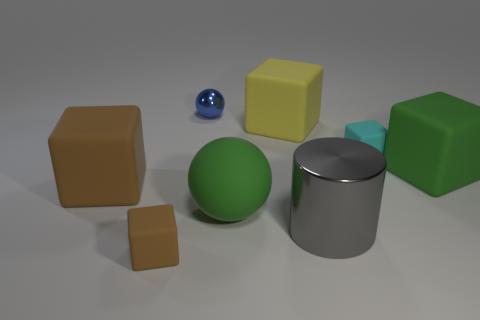Subtract 1 blocks. How many blocks are left? 4 Subtract all cyan rubber blocks. How many blocks are left? 4 Subtract all red cubes. Subtract all red cylinders. How many cubes are left? 5 Add 1 green blocks. How many objects exist? 9 Subtract all cylinders. How many objects are left? 7 Add 3 large metal things. How many large metal things exist? 4 Subtract 0 blue cylinders. How many objects are left? 8 Subtract all large metal cylinders. Subtract all blocks. How many objects are left? 2 Add 2 large gray shiny objects. How many large gray shiny objects are left? 3 